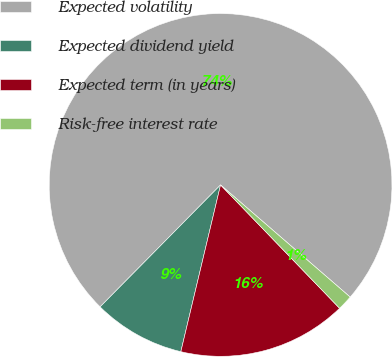<chart> <loc_0><loc_0><loc_500><loc_500><pie_chart><fcel>Expected volatility<fcel>Expected dividend yield<fcel>Expected term (in years)<fcel>Risk-free interest rate<nl><fcel>73.95%<fcel>8.68%<fcel>15.94%<fcel>1.43%<nl></chart> 